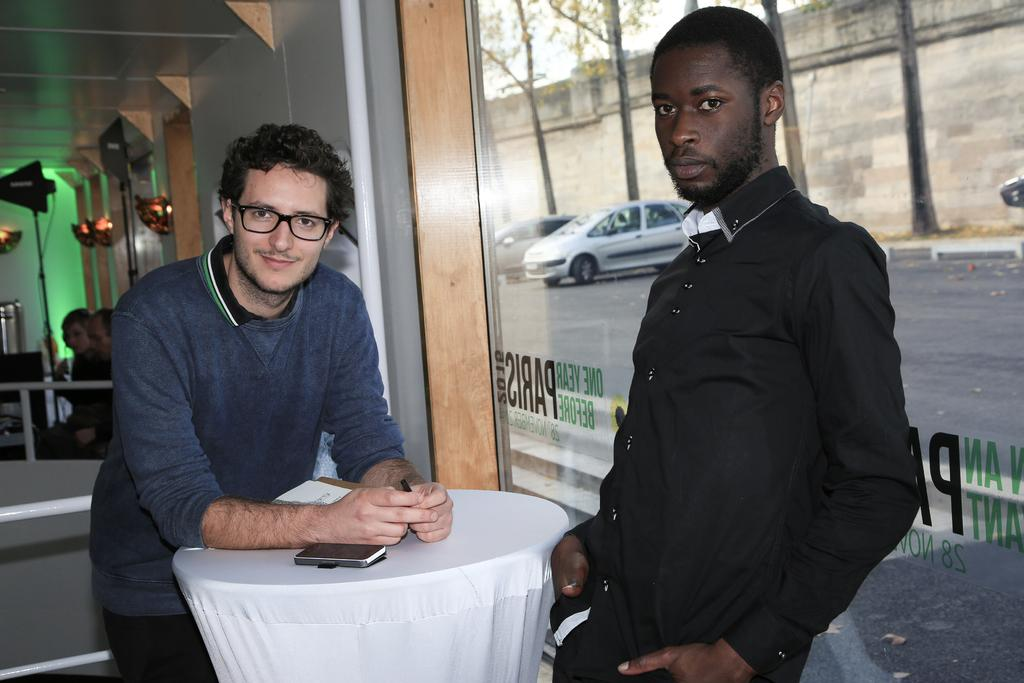How many people are in the image? There are two people in the image. What are the people doing in the image? The people are standing on the floor. What can be seen on the right side of the image? A car is parked on the right side of the image. What type of clothing are the people wearing? Both people are wearing shirts and pants. What type of pig can be seen in the image? There is no pig present in the image. What drug is being discussed by the people in the image? There is no drug mentioned or depicted in the image. 